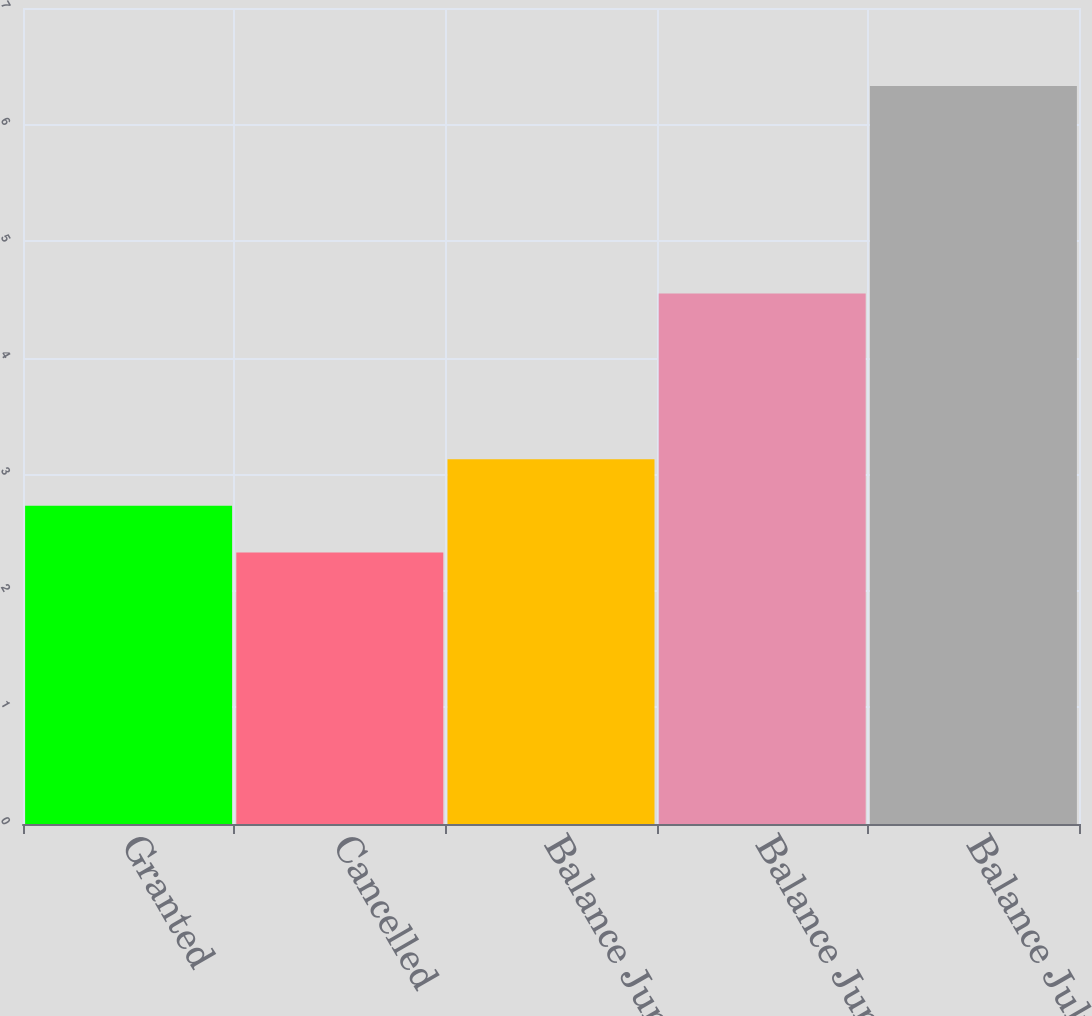<chart> <loc_0><loc_0><loc_500><loc_500><bar_chart><fcel>Granted<fcel>Cancelled<fcel>Balance June 28 2002<fcel>Balance June 27 2003<fcel>Balance July 2 2004<nl><fcel>2.73<fcel>2.33<fcel>3.13<fcel>4.55<fcel>6.33<nl></chart> 